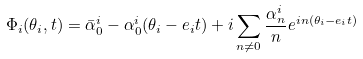Convert formula to latex. <formula><loc_0><loc_0><loc_500><loc_500>\Phi _ { i } ( \theta _ { i } , t ) = \bar { \alpha } ^ { i } _ { 0 } - \alpha ^ { i } _ { 0 } ( \theta _ { i } - e _ { i } t ) + i \sum _ { n \neq 0 } \frac { \alpha _ { n } ^ { i } } { n } e ^ { i n ( \theta _ { i } - e _ { i } t ) }</formula> 